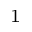Convert formula to latex. <formula><loc_0><loc_0><loc_500><loc_500>^ { 1 }</formula> 